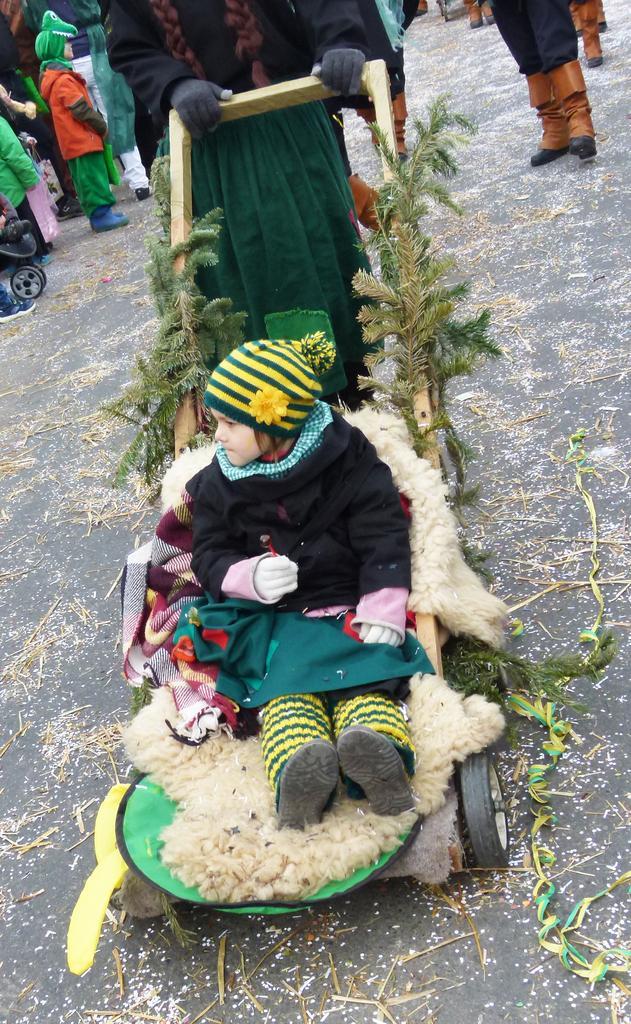Please provide a concise description of this image. In this image I see a trolley on which there is a child sitting on it and I see the leaves and I see that a person is holding this trolley and I see the road. In the background I see few more people. 